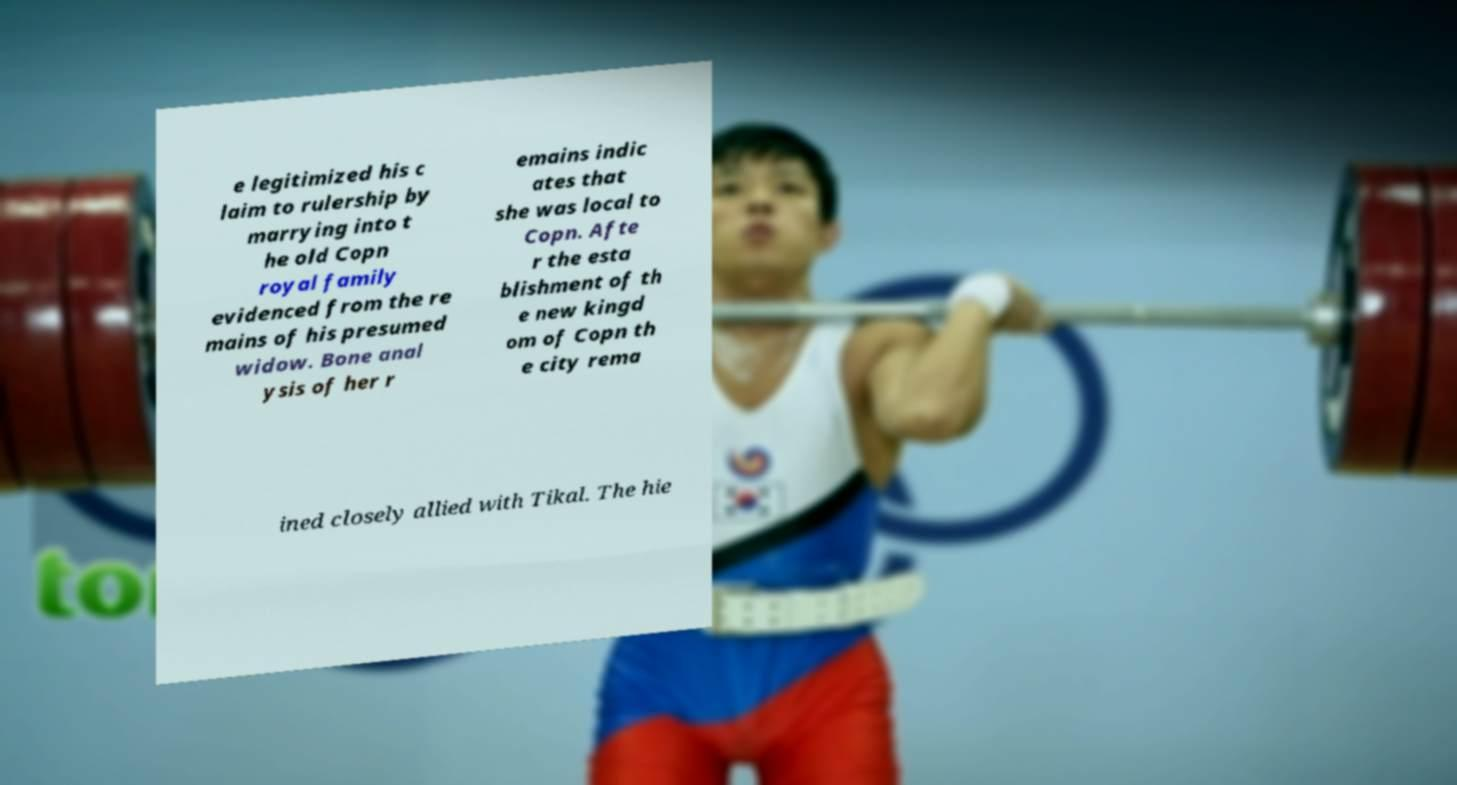There's text embedded in this image that I need extracted. Can you transcribe it verbatim? e legitimized his c laim to rulership by marrying into t he old Copn royal family evidenced from the re mains of his presumed widow. Bone anal ysis of her r emains indic ates that she was local to Copn. Afte r the esta blishment of th e new kingd om of Copn th e city rema ined closely allied with Tikal. The hie 